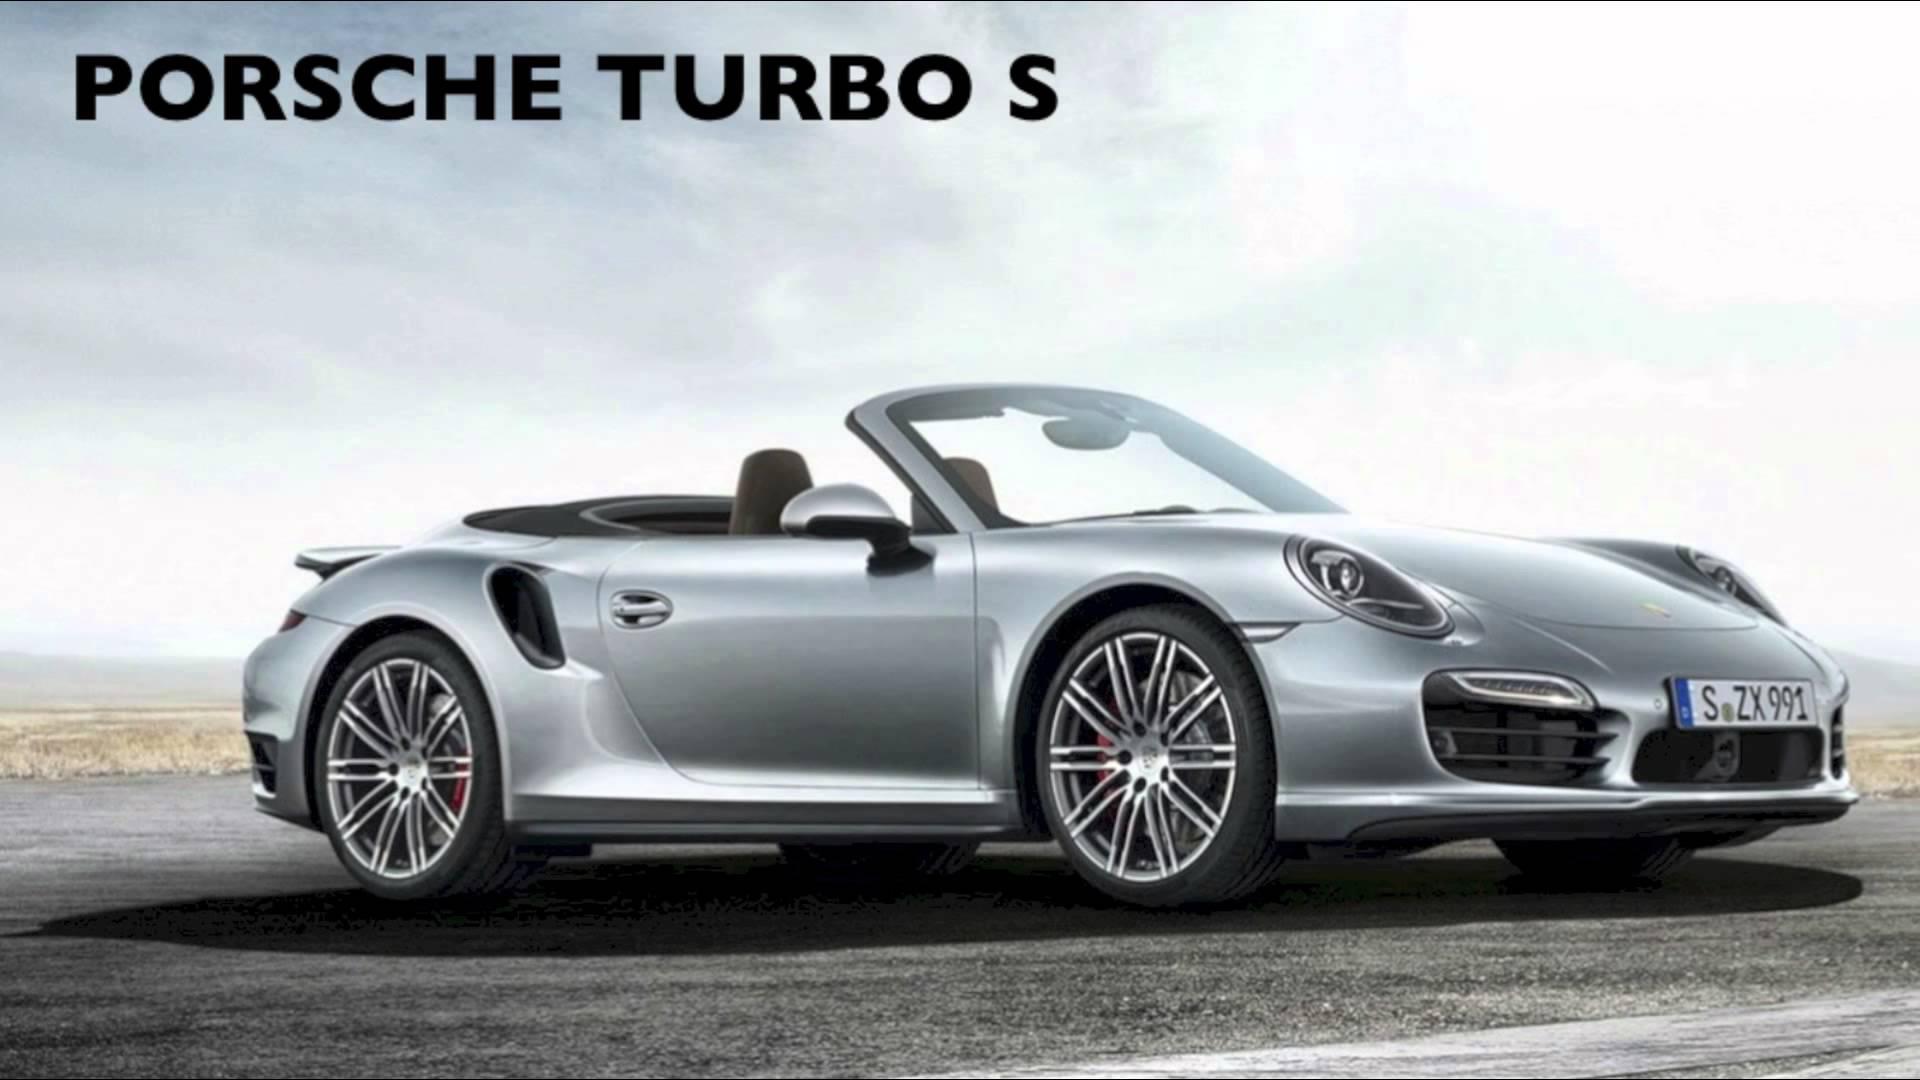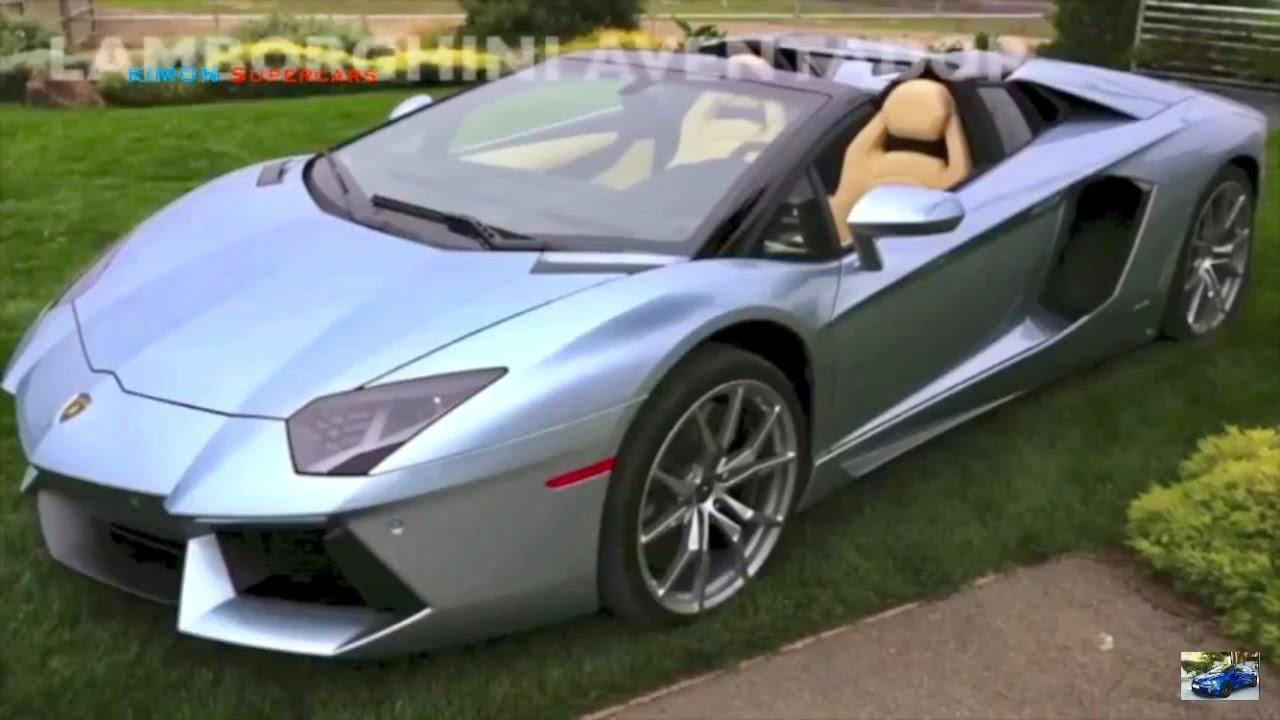The first image is the image on the left, the second image is the image on the right. For the images displayed, is the sentence "All the cars are white." factually correct? Answer yes or no. No. 